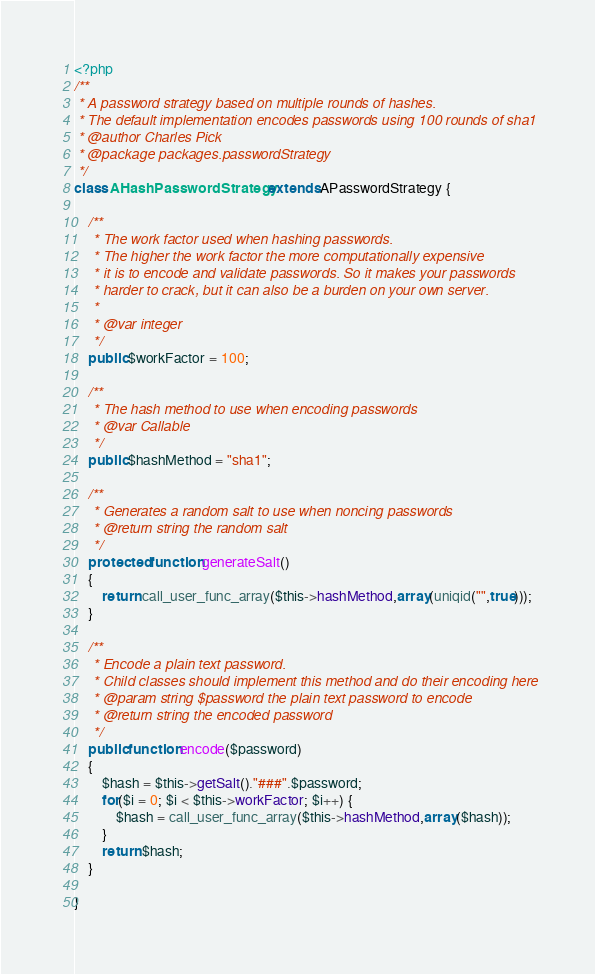Convert code to text. <code><loc_0><loc_0><loc_500><loc_500><_PHP_><?php
/**
 * A password strategy based on multiple rounds of hashes.
 * The default implementation encodes passwords using 100 rounds of sha1
 * @author Charles Pick
 * @package packages.passwordStrategy
 */
class AHashPasswordStrategy extends APasswordStrategy {

	/**
	 * The work factor used when hashing passwords.
	 * The higher the work factor the more computationally expensive
	 * it is to encode and validate passwords. So it makes your passwords
	 * harder to crack, but it can also be a burden on your own server.
	 *
	 * @var integer
	 */
	public $workFactor = 100;

	/**
	 * The hash method to use when encoding passwords
	 * @var Callable
	 */
	public $hashMethod = "sha1";

	/**
	 * Generates a random salt to use when noncing passwords
	 * @return string the random salt
	 */
	protected function generateSalt()
	{
		return call_user_func_array($this->hashMethod,array(uniqid("",true)));
	}

	/**
	 * Encode a plain text password.
	 * Child classes should implement this method and do their encoding here
	 * @param string $password the plain text password to encode
	 * @return string the encoded password
	 */
	public function encode($password)
	{
		$hash = $this->getSalt()."###".$password;
		for($i = 0; $i < $this->workFactor; $i++) {
			$hash = call_user_func_array($this->hashMethod,array($hash));
		}
		return $hash;
	}

}</code> 